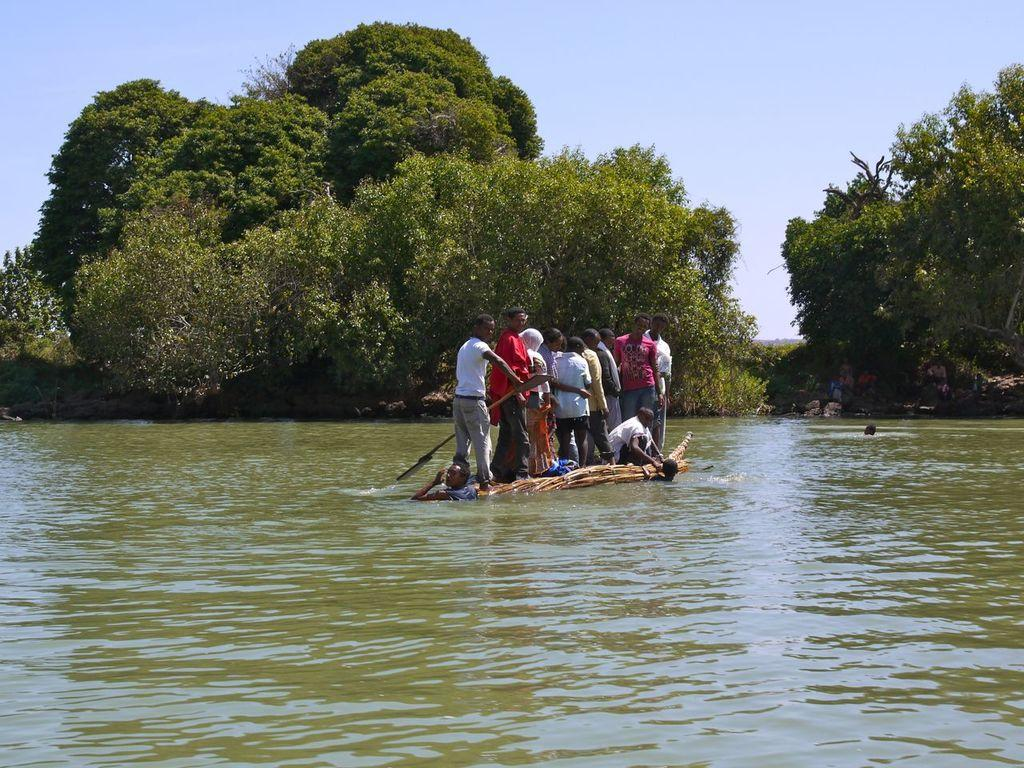What are the people doing in the image? The people are standing on a wooden boat in the image. What can be seen in the background of the image? There are trees visible in the background of the image. What is visible at the top of the image? The sky is visible at the top of the image. What is the boat sailing on? The boat is sailing in water. Can you tell me which organization owns the key to the boat in the image? There is no key or reference to an organization present in the image. 